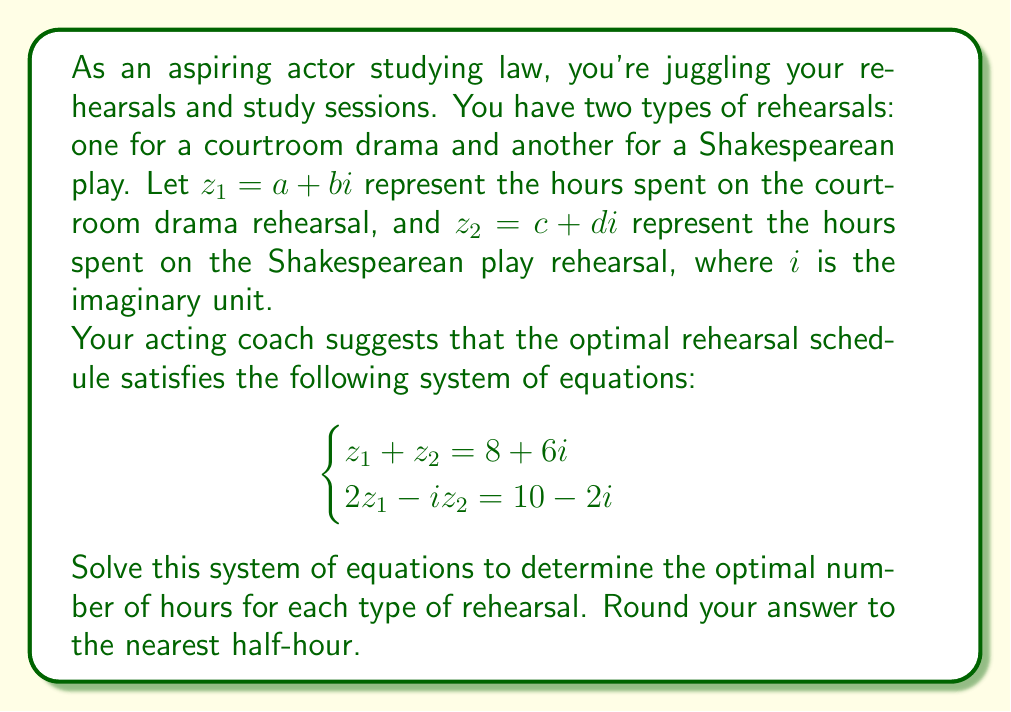Could you help me with this problem? Let's solve this step-by-step:

1) We have $z_1 = a + bi$ and $z_2 = c + di$. Let's substitute these into our system of equations:

   $$(a + bi) + (c + di) = 8 + 6i$$
   $$2(a + bi) - i(c + di) = 10 - 2i$$

2) From the first equation, we can equate real and imaginary parts:
   
   $a + c = 8$
   $b + d = 6$

3) For the second equation, let's expand and then equate real and imaginary parts:
   
   $(2a + 2bi) - (ci + di^2) = 10 - 2i$
   $(2a + 2bi) - (ci - d) = 10 - 2i$
   
   $2a + d = 10$
   $2b - c = -2$

4) Now we have a system of four equations with four unknowns:

   $$\begin{cases}
   a + c = 8 \\
   b + d = 6 \\
   2a + d = 10 \\
   2b - c = -2
   \end{cases}$$

5) From the third equation: $d = 10 - 2a$
   Substitute this into the first equation:
   $a + c = 8$
   $c = 8 - a$

6) Now substitute these into the fourth equation:
   $2b - (8 - a) = -2$
   $2b + a = 6$
   $b = 3 - \frac{a}{2}$

7) Finally, substitute this into the second equation:
   $(3 - \frac{a}{2}) + (10 - 2a) = 6$
   $13 - \frac{5a}{2} = 6$
   $-\frac{5a}{2} = -7$
   $a = \frac{14}{5} = 2.8$

8) Now we can find the other values:
   $b = 3 - \frac{2.8}{2} = 1.6$
   $c = 8 - 2.8 = 5.2$
   $d = 10 - 2(2.8) = 4.4$

9) Therefore, $z_1 = 2.8 + 1.6i$ and $z_2 = 5.2 + 4.4i$

10) Rounding to the nearest half-hour:
    $z_1 \approx 3 + 1.5i$
    $z_2 \approx 5 + 4.5i$
Answer: The optimal rehearsal schedule is approximately 3 hours for the courtroom drama rehearsal and 5 hours for the Shakespearean play rehearsal, with 1.5 hours and 4.5 hours of additional time allocated for each respectively. 